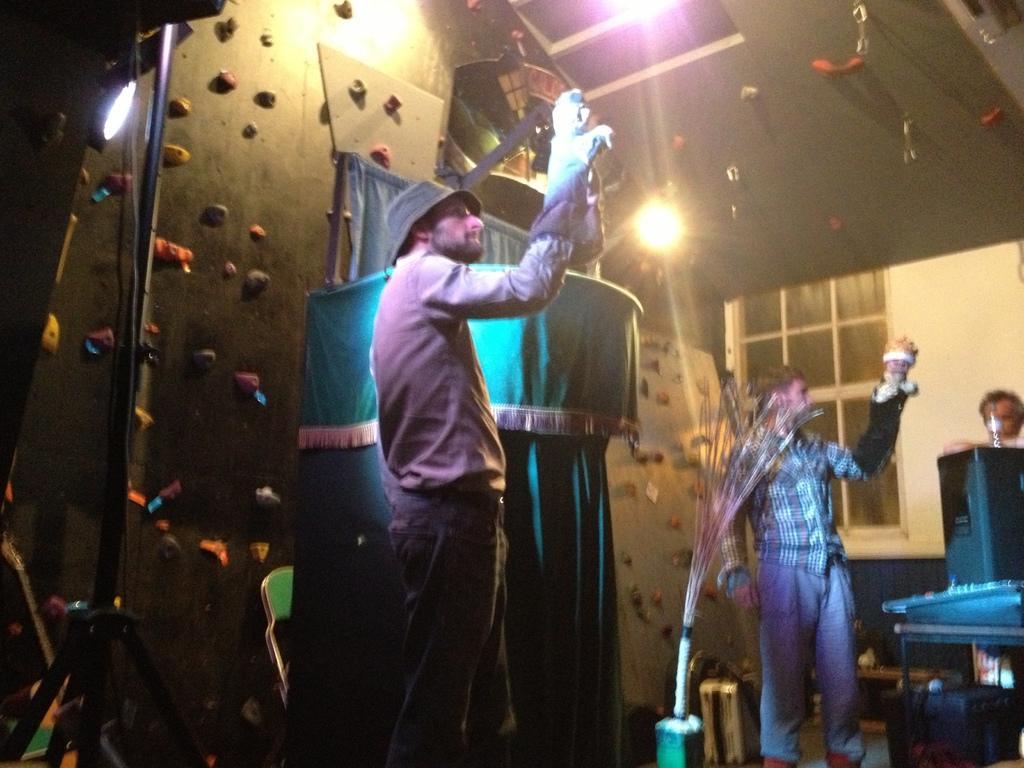How would you summarize this image in a sentence or two? There is some event is being conducted there are two men and they are holding dolls with their hands and behind the men there is a pit covered with cloth and on the right side there is a window and a person is standing beside the window, there is a speaker and some other equipment it in front of that person and there are different colors of lights falling on them. 